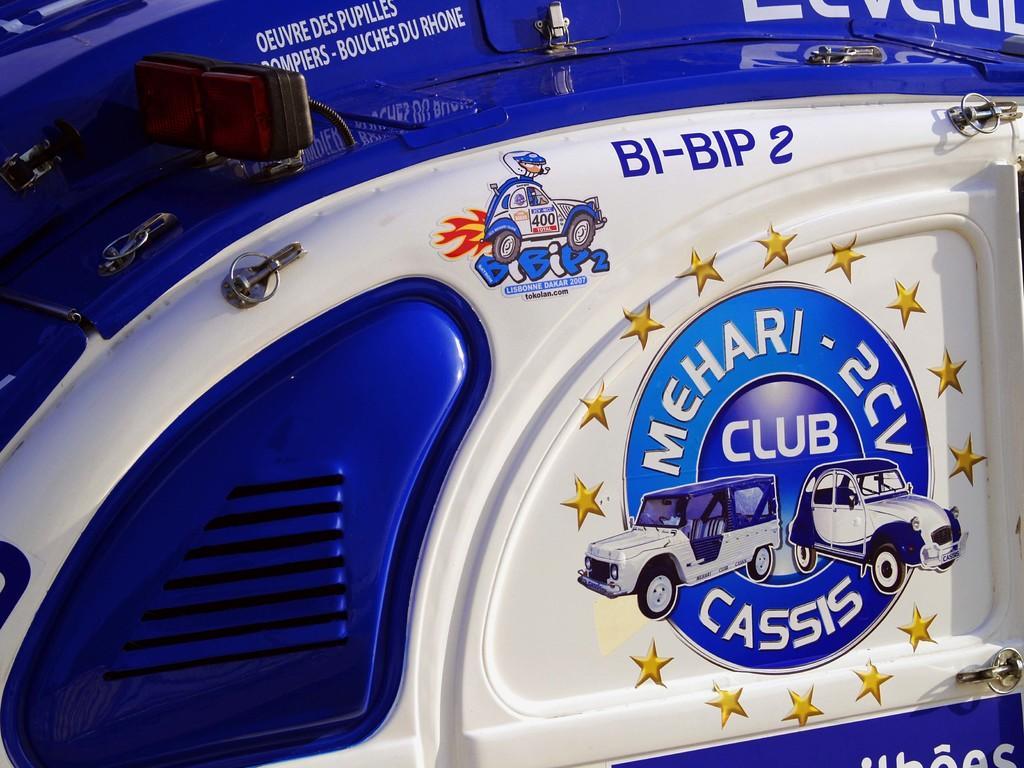Please provide a concise description of this image. In this image, we can see a blue and white color object, there are some pictures of the cars on the object. 